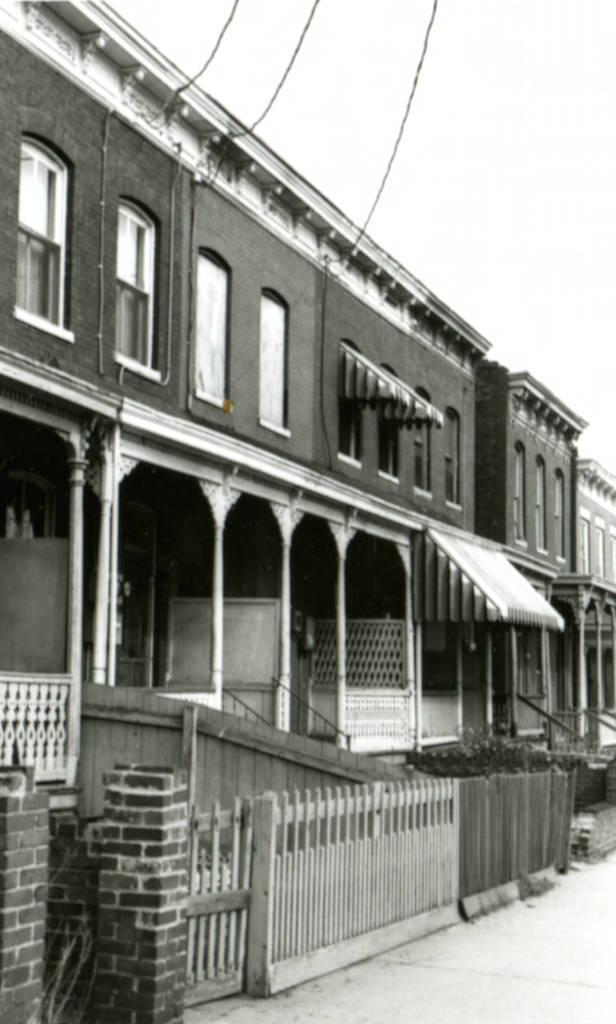What type of structure can be seen in the image? There is a building in the image. What else is present in the image besides the building? There are wires, sky, a wall to the left, a road, plants, a gate, and windows visible in the image. What is the writer's son doing in the image? There is no writer or son present in the image. Can you see any ants in the image? There are no ants visible in the image. 